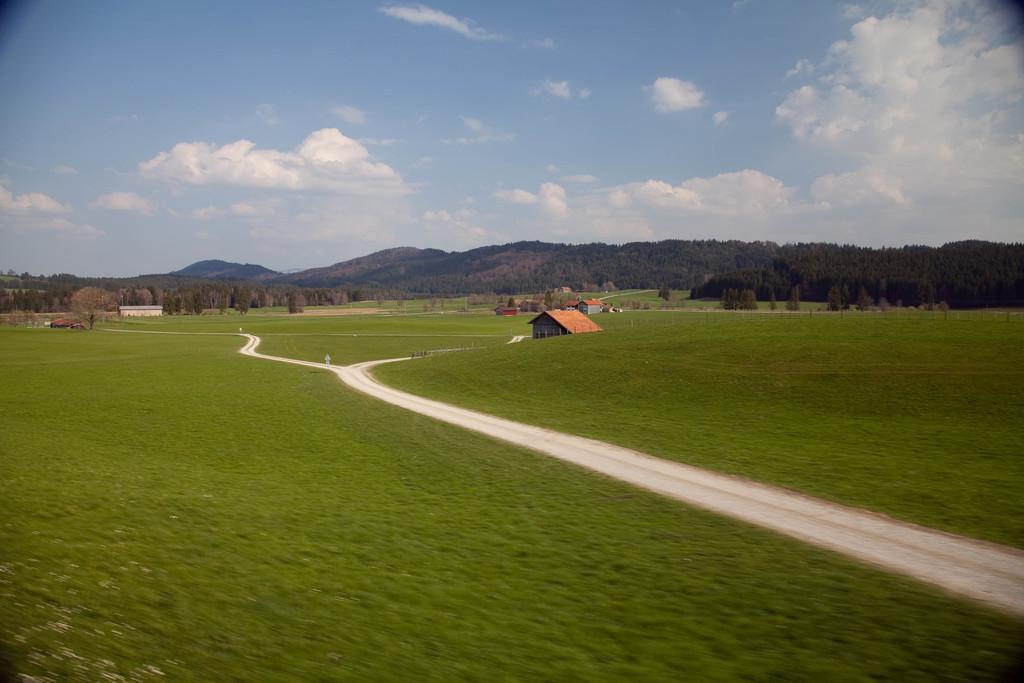Could you give a brief overview of what you see in this image? In the image we can see houses, trees and hills. Here we can see grass, paths and the cloudy sky. 